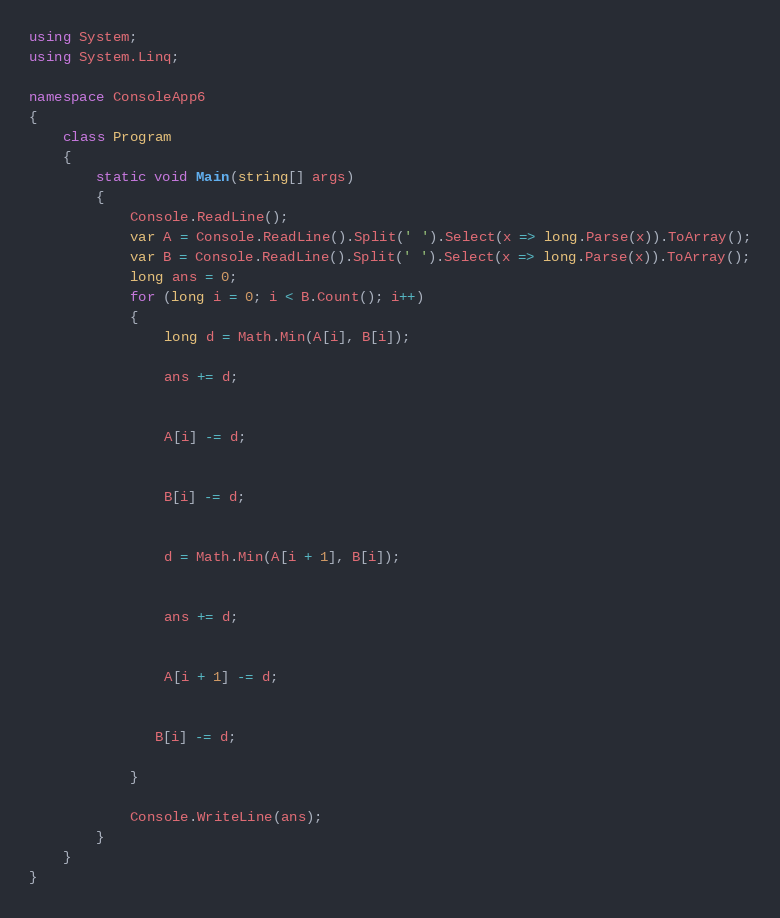<code> <loc_0><loc_0><loc_500><loc_500><_C#_>using System;
using System.Linq;

namespace ConsoleApp6
{
    class Program
    {
        static void Main(string[] args)
        {
            Console.ReadLine();
            var A = Console.ReadLine().Split(' ').Select(x => long.Parse(x)).ToArray();
            var B = Console.ReadLine().Split(' ').Select(x => long.Parse(x)).ToArray();
            long ans = 0;
            for (long i = 0; i < B.Count(); i++)
            {
                long d = Math.Min(A[i], B[i]);

                ans += d;


                A[i] -= d;


                B[i] -= d;


                d = Math.Min(A[i + 1], B[i]);


                ans += d;


                A[i + 1] -= d;


               B[i] -= d;

            }

            Console.WriteLine(ans);
        }
    }
}</code> 